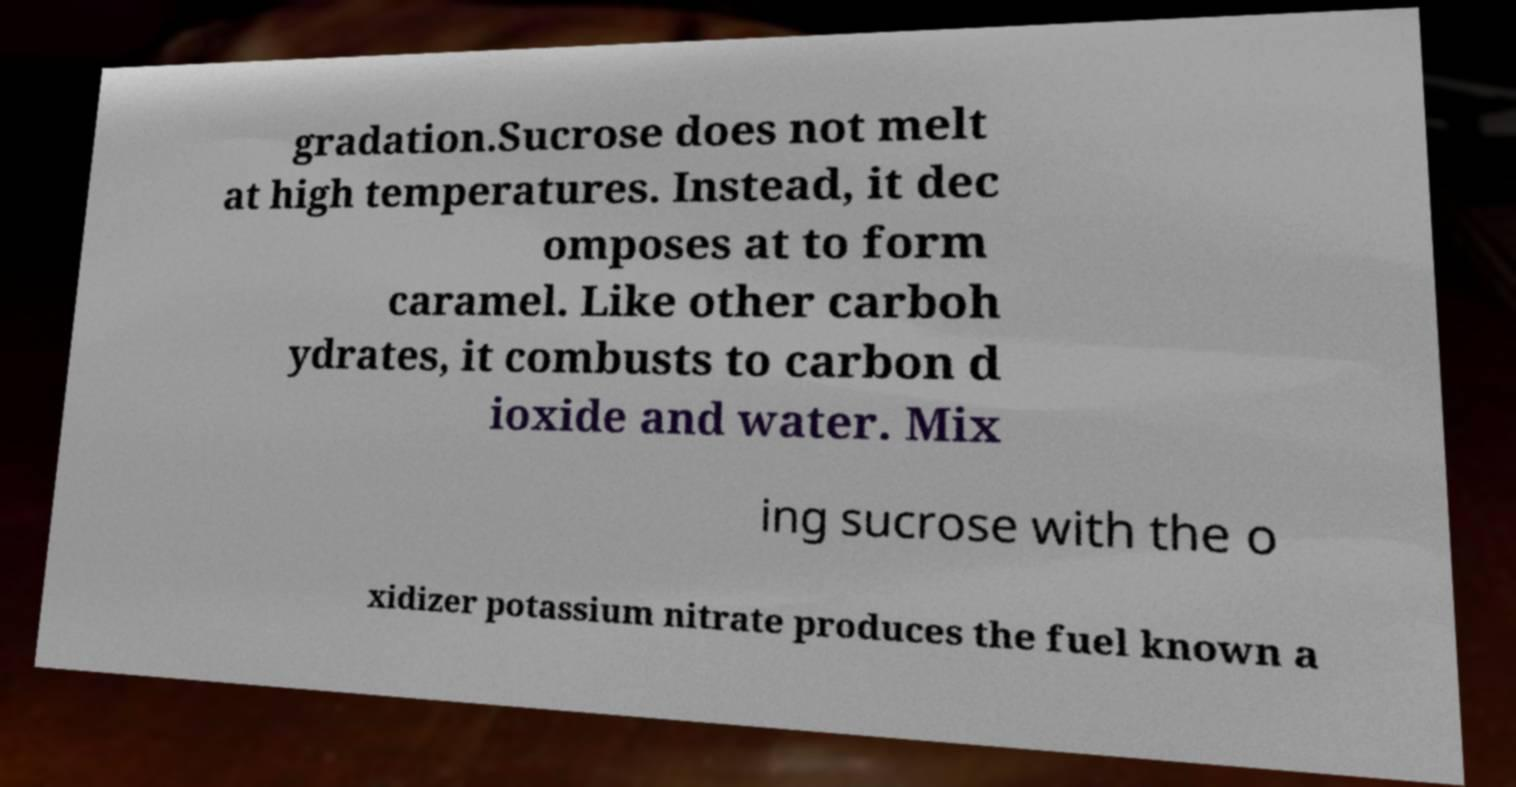Could you extract and type out the text from this image? gradation.Sucrose does not melt at high temperatures. Instead, it dec omposes at to form caramel. Like other carboh ydrates, it combusts to carbon d ioxide and water. Mix ing sucrose with the o xidizer potassium nitrate produces the fuel known a 